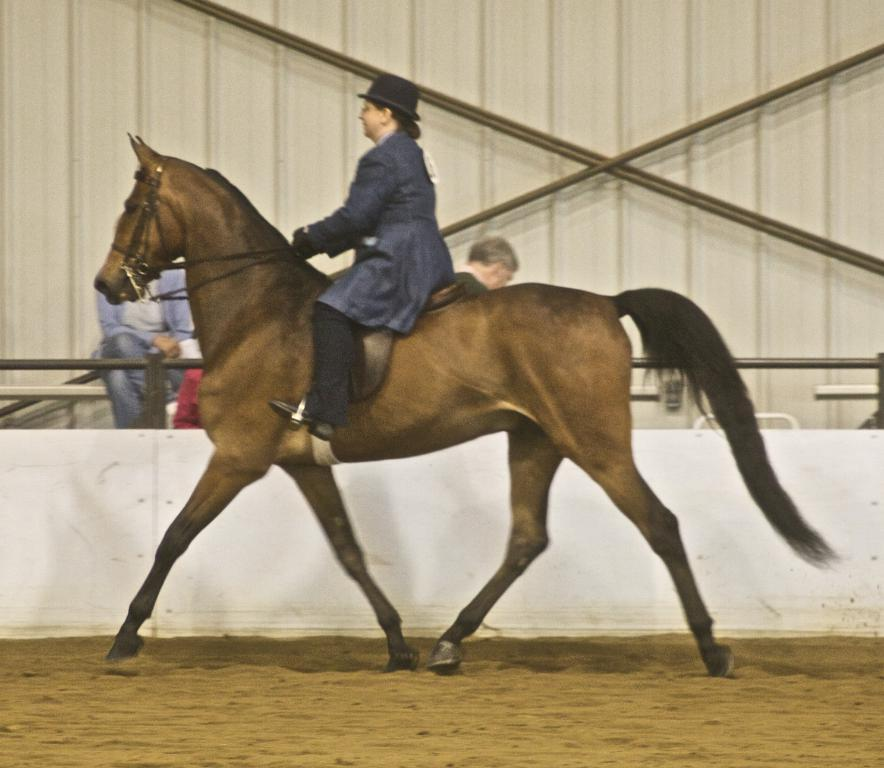What is the main subject of the image? There is a person riding a horse in the image. What is the person wearing on their head? The person is wearing a hat. What type of terrain is visible in the image? The scene takes place in the sand. Are there any other people present in the image? Yes, there are people sitting behind the person riding the horse. What can be seen in the background of the image? There is a white wall in the background of the image. What type of powder is being used by the coach in the image? There is no coach or powder present in the image. 